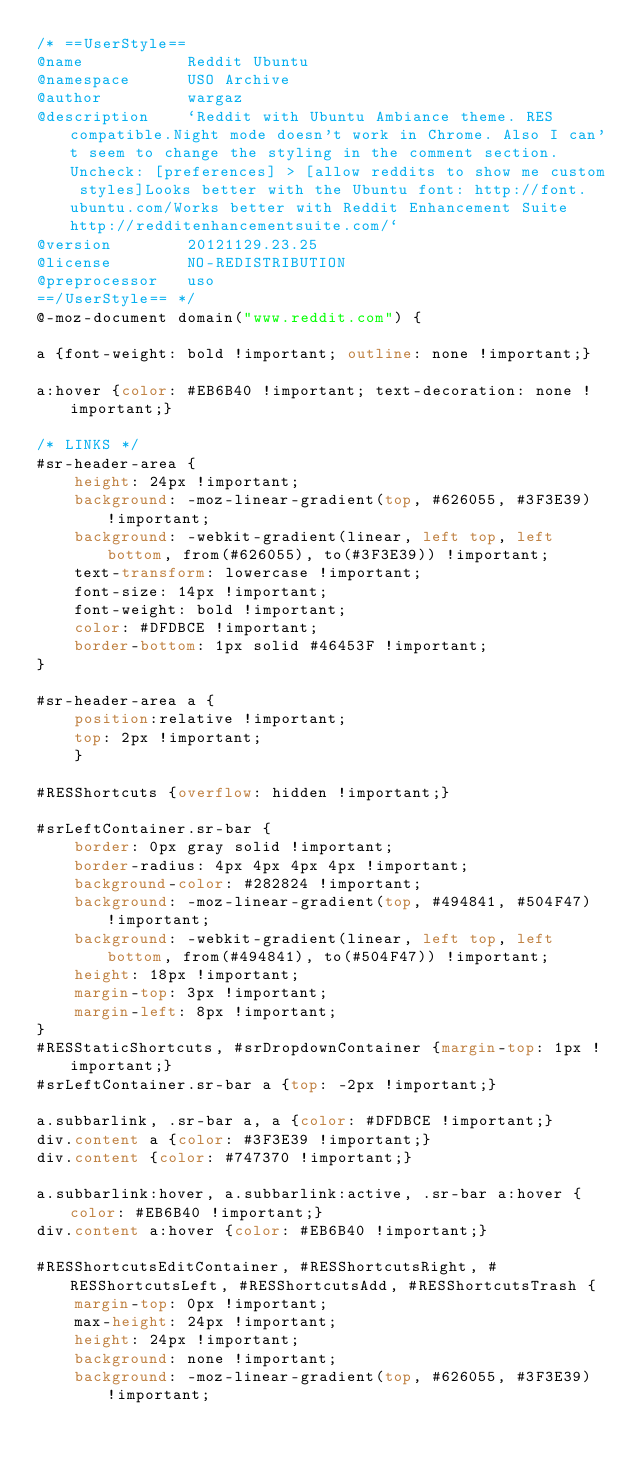Convert code to text. <code><loc_0><loc_0><loc_500><loc_500><_CSS_>/* ==UserStyle==
@name           Reddit Ubuntu
@namespace      USO Archive
@author         wargaz
@description    `Reddit with Ubuntu Ambiance theme. RES compatible.Night mode doesn't work in Chrome. Also I can't seem to change the styling in the comment section.Uncheck: [preferences] > [allow reddits to show me custom styles]Looks better with the Ubuntu font: http://font.ubuntu.com/Works better with Reddit Enhancement Suite http://redditenhancementsuite.com/`
@version        20121129.23.25
@license        NO-REDISTRIBUTION
@preprocessor   uso
==/UserStyle== */
@-moz-document domain("www.reddit.com") {

a {font-weight: bold !important; outline: none !important;}

a:hover {color: #EB6B40 !important; text-decoration: none !important;}

/* LINKS */
#sr-header-area {
    height: 24px !important;
    background: -moz-linear-gradient(top, #626055, #3F3E39) !important;
    background: -webkit-gradient(linear, left top, left bottom, from(#626055), to(#3F3E39)) !important;
    text-transform: lowercase !important;
    font-size: 14px !important;
    font-weight: bold !important;
    color: #DFDBCE !important;
    border-bottom: 1px solid #46453F !important;
}

#sr-header-area a {
    position:relative !important;
    top: 2px !important;
    }
    
#RESShortcuts {overflow: hidden !important;}

#srLeftContainer.sr-bar {
    border: 0px gray solid !important;
    border-radius: 4px 4px 4px 4px !important;
    background-color: #282824 !important;
    background: -moz-linear-gradient(top, #494841, #504F47) !important;
    background: -webkit-gradient(linear, left top, left bottom, from(#494841), to(#504F47)) !important;
    height: 18px !important;
    margin-top: 3px !important;
    margin-left: 8px !important;
}
#RESStaticShortcuts, #srDropdownContainer {margin-top: 1px !important;}
#srLeftContainer.sr-bar a {top: -2px !important;}

a.subbarlink, .sr-bar a, a {color: #DFDBCE !important;}
div.content a {color: #3F3E39 !important;}
div.content {color: #747370 !important;}

a.subbarlink:hover, a.subbarlink:active, .sr-bar a:hover {color: #EB6B40 !important;}
div.content a:hover {color: #EB6B40 !important;}

#RESShortcutsEditContainer, #RESShortcutsRight, #RESShortcutsLeft, #RESShortcutsAdd, #RESShortcutsTrash {
    margin-top: 0px !important;
    max-height: 24px !important;
    height: 24px !important;
    background: none !important;
    background: -moz-linear-gradient(top, #626055, #3F3E39) !important;</code> 